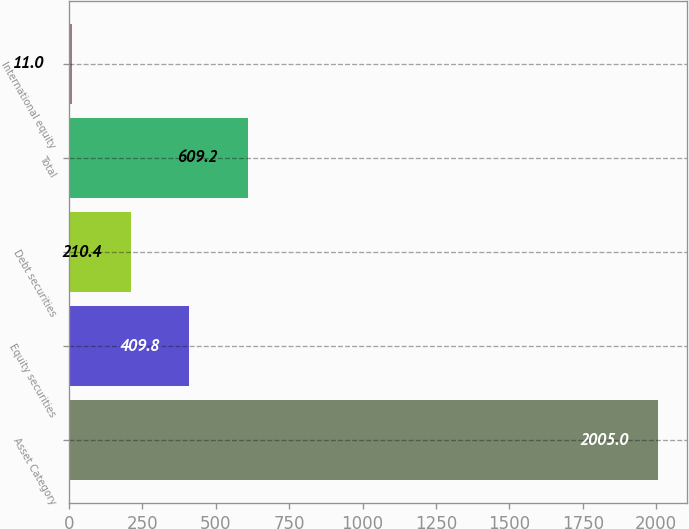Convert chart. <chart><loc_0><loc_0><loc_500><loc_500><bar_chart><fcel>Asset Category<fcel>Equity securities<fcel>Debt securities<fcel>Total<fcel>International equity<nl><fcel>2005<fcel>409.8<fcel>210.4<fcel>609.2<fcel>11<nl></chart> 